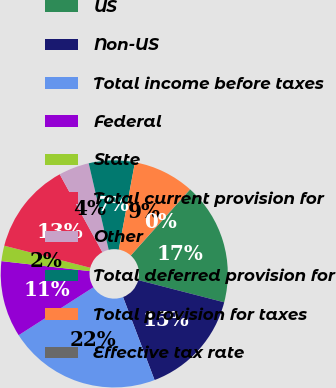<chart> <loc_0><loc_0><loc_500><loc_500><pie_chart><fcel>US<fcel>Non-US<fcel>Total income before taxes<fcel>Federal<fcel>State<fcel>Total current provision for<fcel>Other<fcel>Total deferred provision for<fcel>Total provision for taxes<fcel>Effective tax rate<nl><fcel>17.37%<fcel>15.2%<fcel>21.7%<fcel>10.87%<fcel>2.2%<fcel>13.03%<fcel>4.36%<fcel>6.53%<fcel>8.7%<fcel>0.03%<nl></chart> 